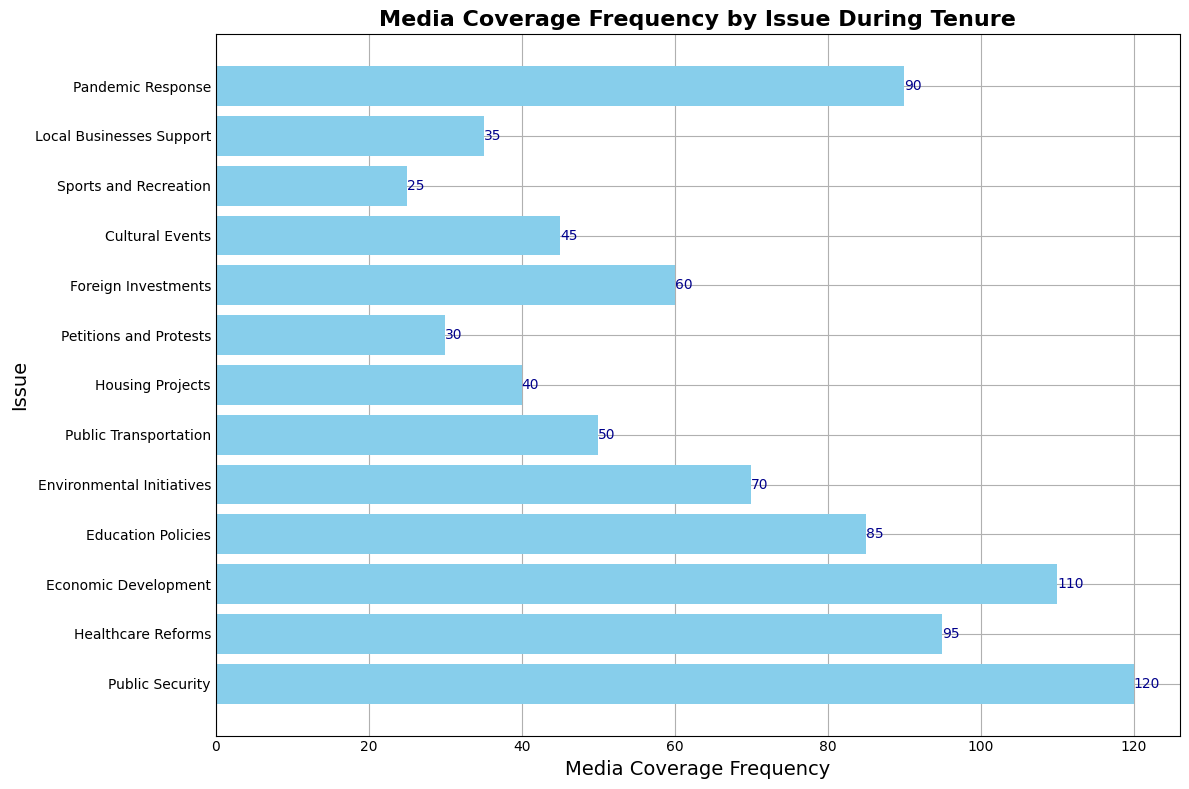Which issue received the highest frequency of media coverage? Look for the bar with the greatest length on the horizontal axis. The "Public Security" issue has the longest bar and the label indicating 120, which is the highest frequency.
Answer: Public Security Which issue has less media coverage frequency than Public Transportation but more than Cultural Events? Identify the bars that represent "Public Transportation" and "Cultural Events". "Public Transportation" has a coverage frequency of 50 and "Cultural Events" has 45. The issue that fits between these two bar lengths is "Foreign Investments" with a frequency of 60.
Answer: Foreign Investments What is the sum of media coverage frequencies for Healthcare Reforms, Economic Development, and Pandemic Response? Add the frequencies of these three issues: Healthcare Reforms (95), Economic Development (110), and Pandemic Response (90). The sum is 95 + 110 + 90 = 295.
Answer: 295 Which two issues have the shortest bars, and hence the least media coverage? Examine the lengths of the bars and identify the two shortest ones. "Sports and Recreation" (25) and "Petitions and Protests" (30) are the shortest.
Answer: Sports and Recreation, Petitions and Protests How much more media coverage did Public Security receive compared to Housing Projects? Determine the frequencies of both issues: Public Security (120) and Housing Projects (40). Calculate the difference: 120 - 40 = 80.
Answer: 80 What is the average media coverage frequency for Environmental Initiatives, Public Transportation, and Local Businesses Support? Add the frequencies of these three issues: Environmental Initiatives (70), Public Transportation (50), and Local Businesses Support (35). The sum is 70 + 50 + 35 = 155. Divide by the number of issues: 155 / 3 ≈ 51.67.
Answer: 51.67 How many issues have a media coverage frequency greater than 80? Scan through the bars and count those with frequencies exceeding 80. Public Security (120), Healthcare Reforms (95), Economic Development (110), and Pandemic Response (90) are greater than 80. There are 4 such issues.
Answer: 4 Which issue has the closest media coverage frequency to 100? Compare all bars' lengths to find the one closest to 100. Economic Development, with a frequency of 110, is the closest to 100.
Answer: Economic Development 